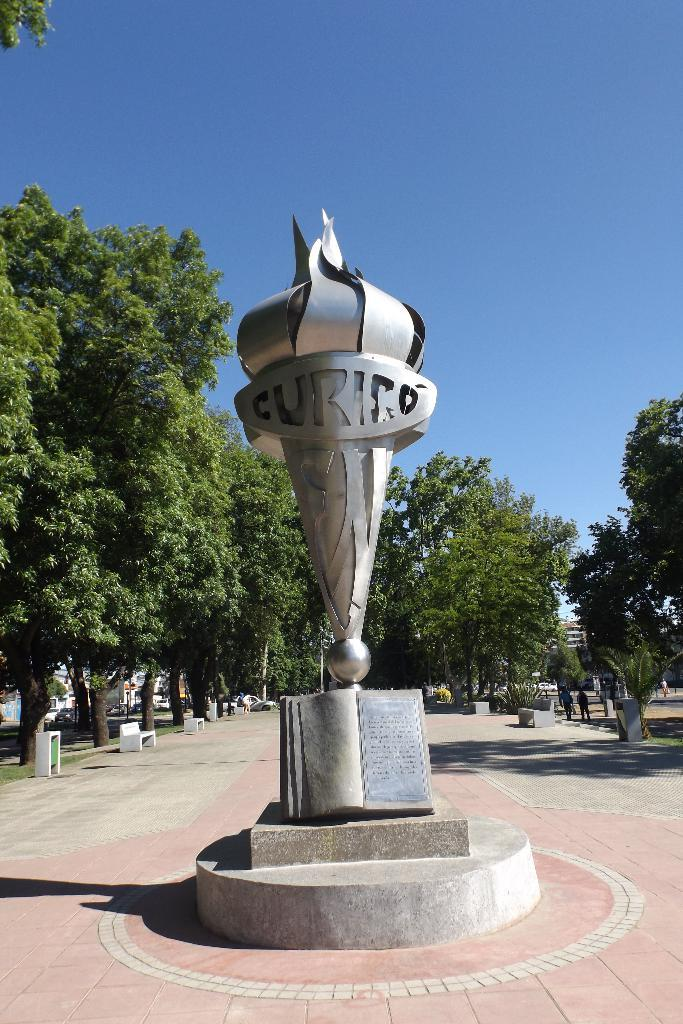<image>
Summarize the visual content of the image. A sculpture in a park shaped like a torch has Curico written on it. 